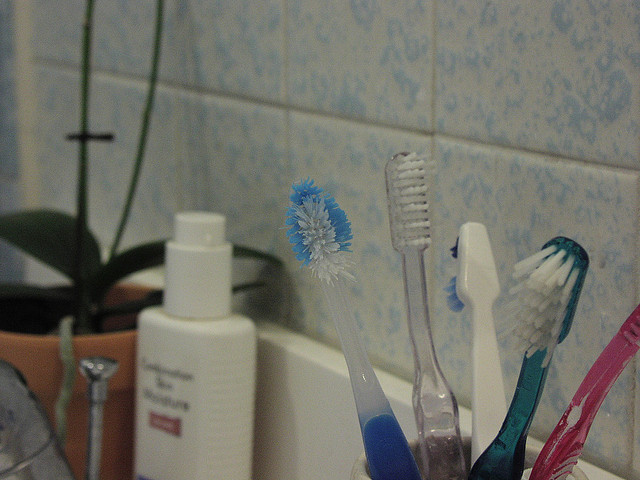<image>What kind of toothpaste is in the photo? There is no toothpaste in the image. However, it could be Crest. What kind of toothpaste is in the photo? There is no toothpaste in the photo. 